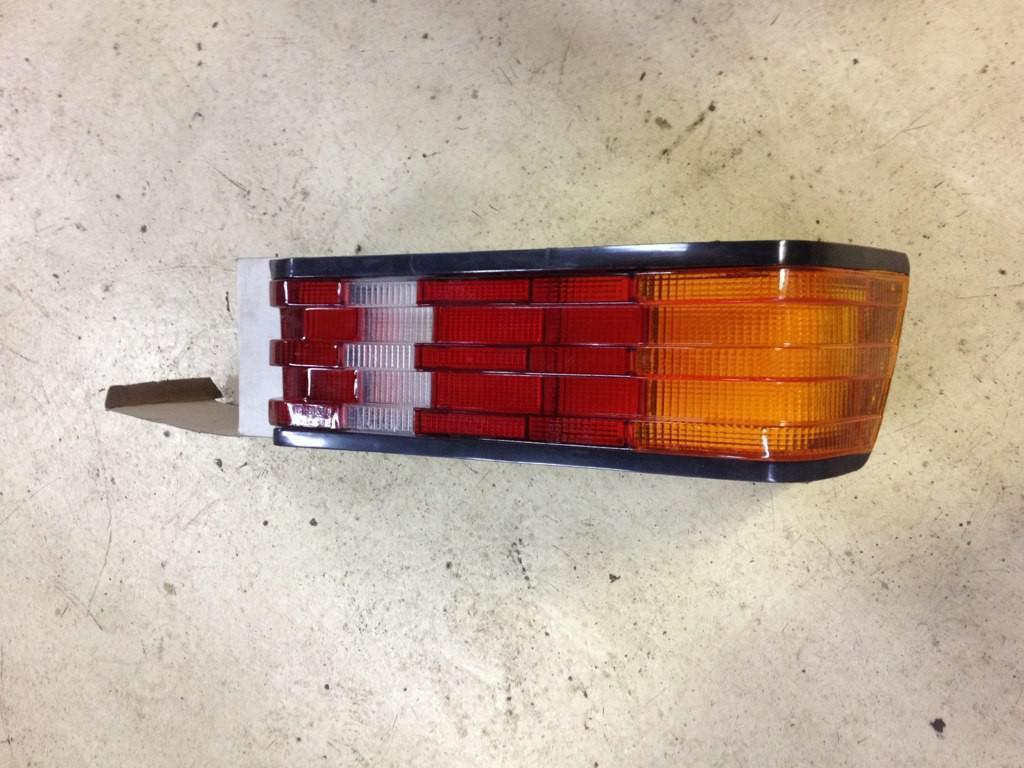Could you give a brief overview of what you see in this image? In the foreground of this image, there is a car rare light part is placed on a card board box which is on the surface. 